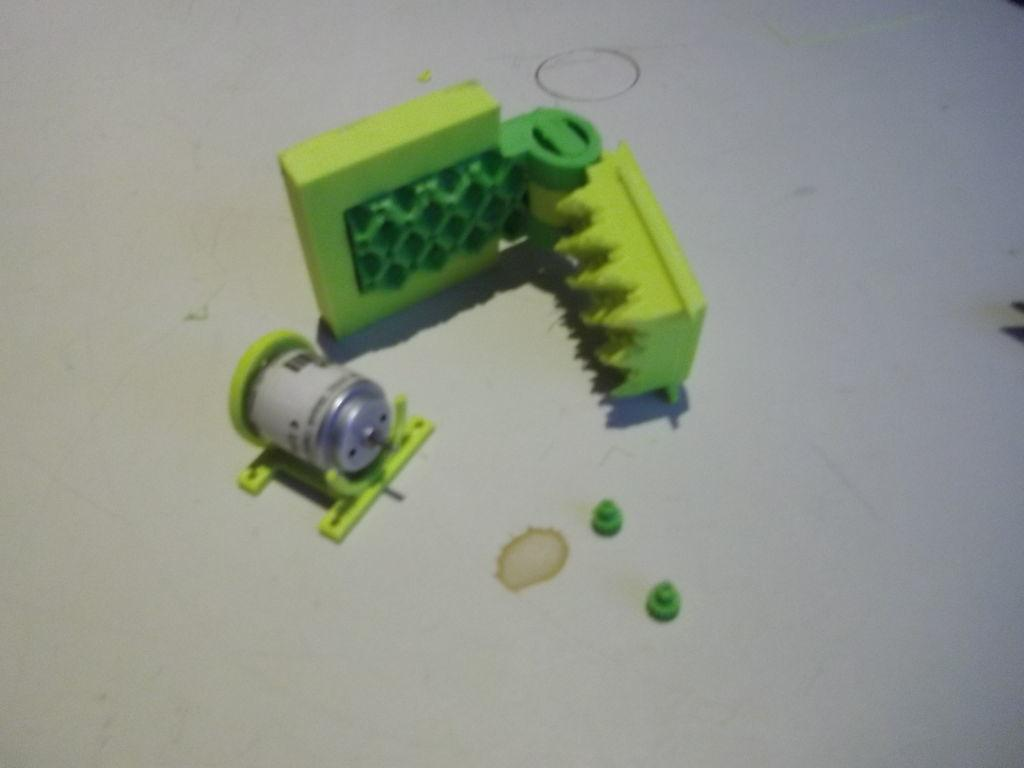What can be seen on the floor in the image? There are objects on the floor in the image. What color is the floor? The floor is white. Is there anything unusual about the floor in the image? Yes, there is a stain on the floor. What type of tax is being discussed in the image? There is no discussion of tax in the image; it only shows objects on a white floor with a stain. 